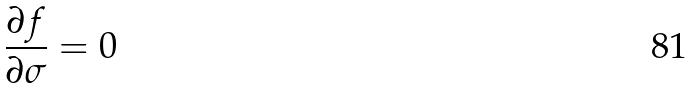<formula> <loc_0><loc_0><loc_500><loc_500>\frac { \partial f } { \partial \sigma } = 0</formula> 